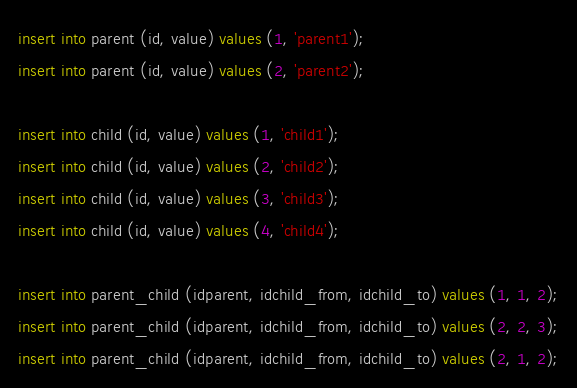<code> <loc_0><loc_0><loc_500><loc_500><_SQL_>insert into parent (id, value) values (1, 'parent1');
insert into parent (id, value) values (2, 'parent2');

insert into child (id, value) values (1, 'child1');
insert into child (id, value) values (2, 'child2');
insert into child (id, value) values (3, 'child3');
insert into child (id, value) values (4, 'child4');

insert into parent_child (idparent, idchild_from, idchild_to) values (1, 1, 2);
insert into parent_child (idparent, idchild_from, idchild_to) values (2, 2, 3);
insert into parent_child (idparent, idchild_from, idchild_to) values (2, 1, 2);</code> 